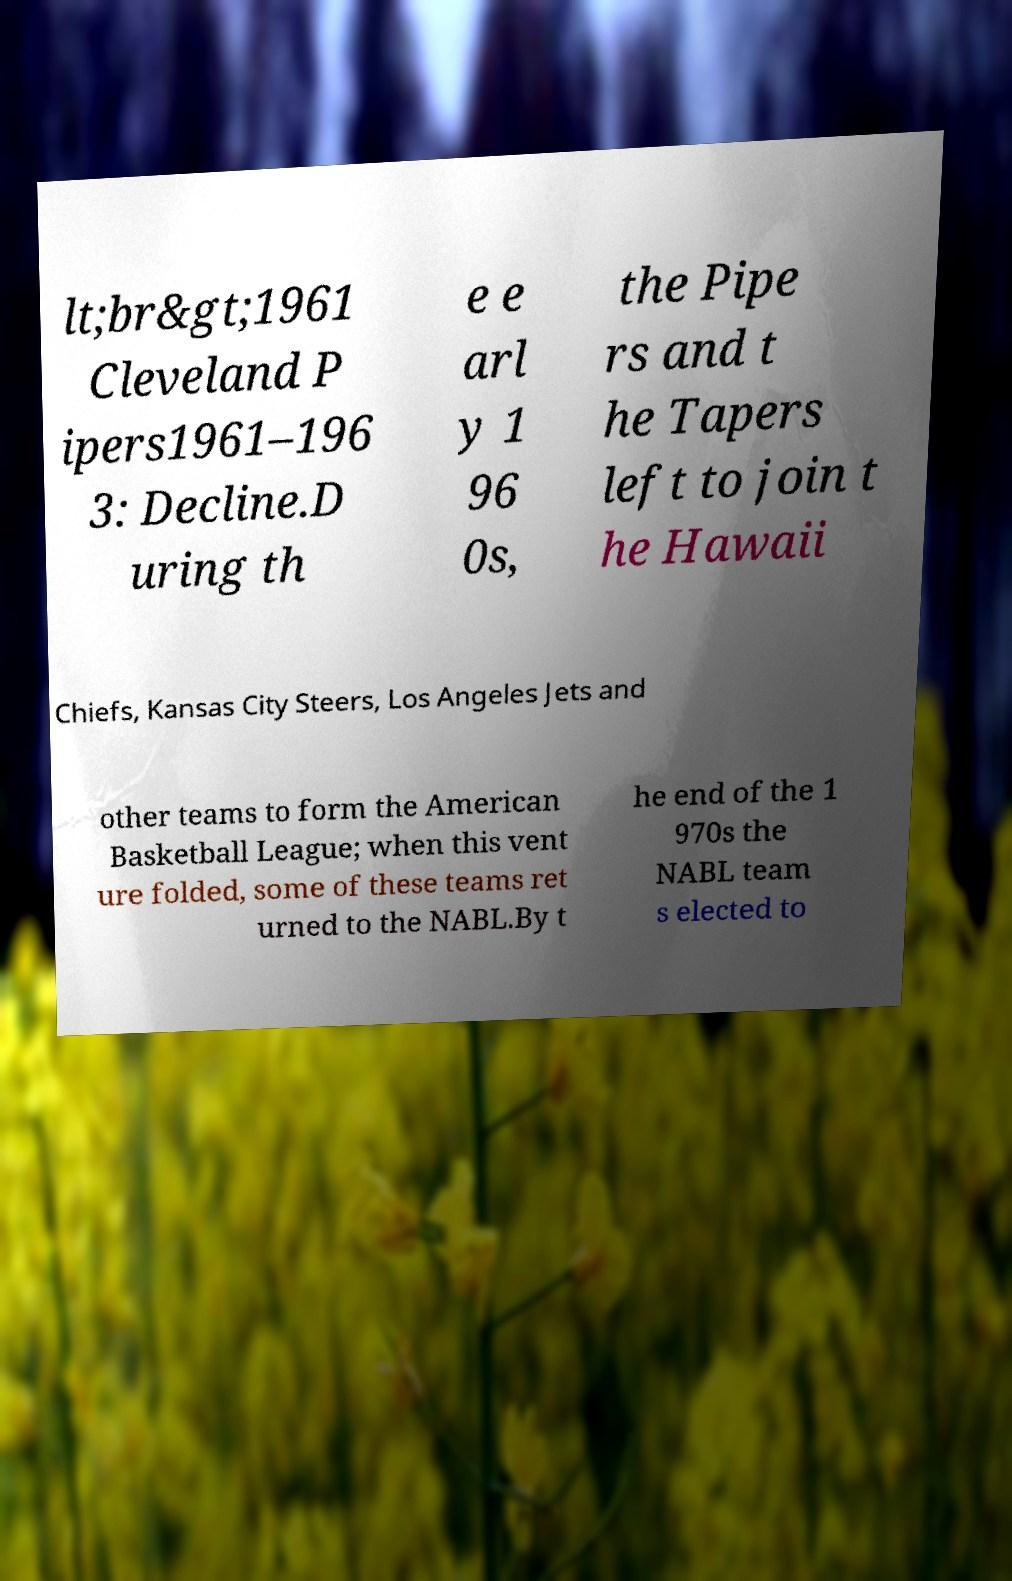Can you accurately transcribe the text from the provided image for me? lt;br&gt;1961 Cleveland P ipers1961–196 3: Decline.D uring th e e arl y 1 96 0s, the Pipe rs and t he Tapers left to join t he Hawaii Chiefs, Kansas City Steers, Los Angeles Jets and other teams to form the American Basketball League; when this vent ure folded, some of these teams ret urned to the NABL.By t he end of the 1 970s the NABL team s elected to 